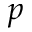<formula> <loc_0><loc_0><loc_500><loc_500>p</formula> 